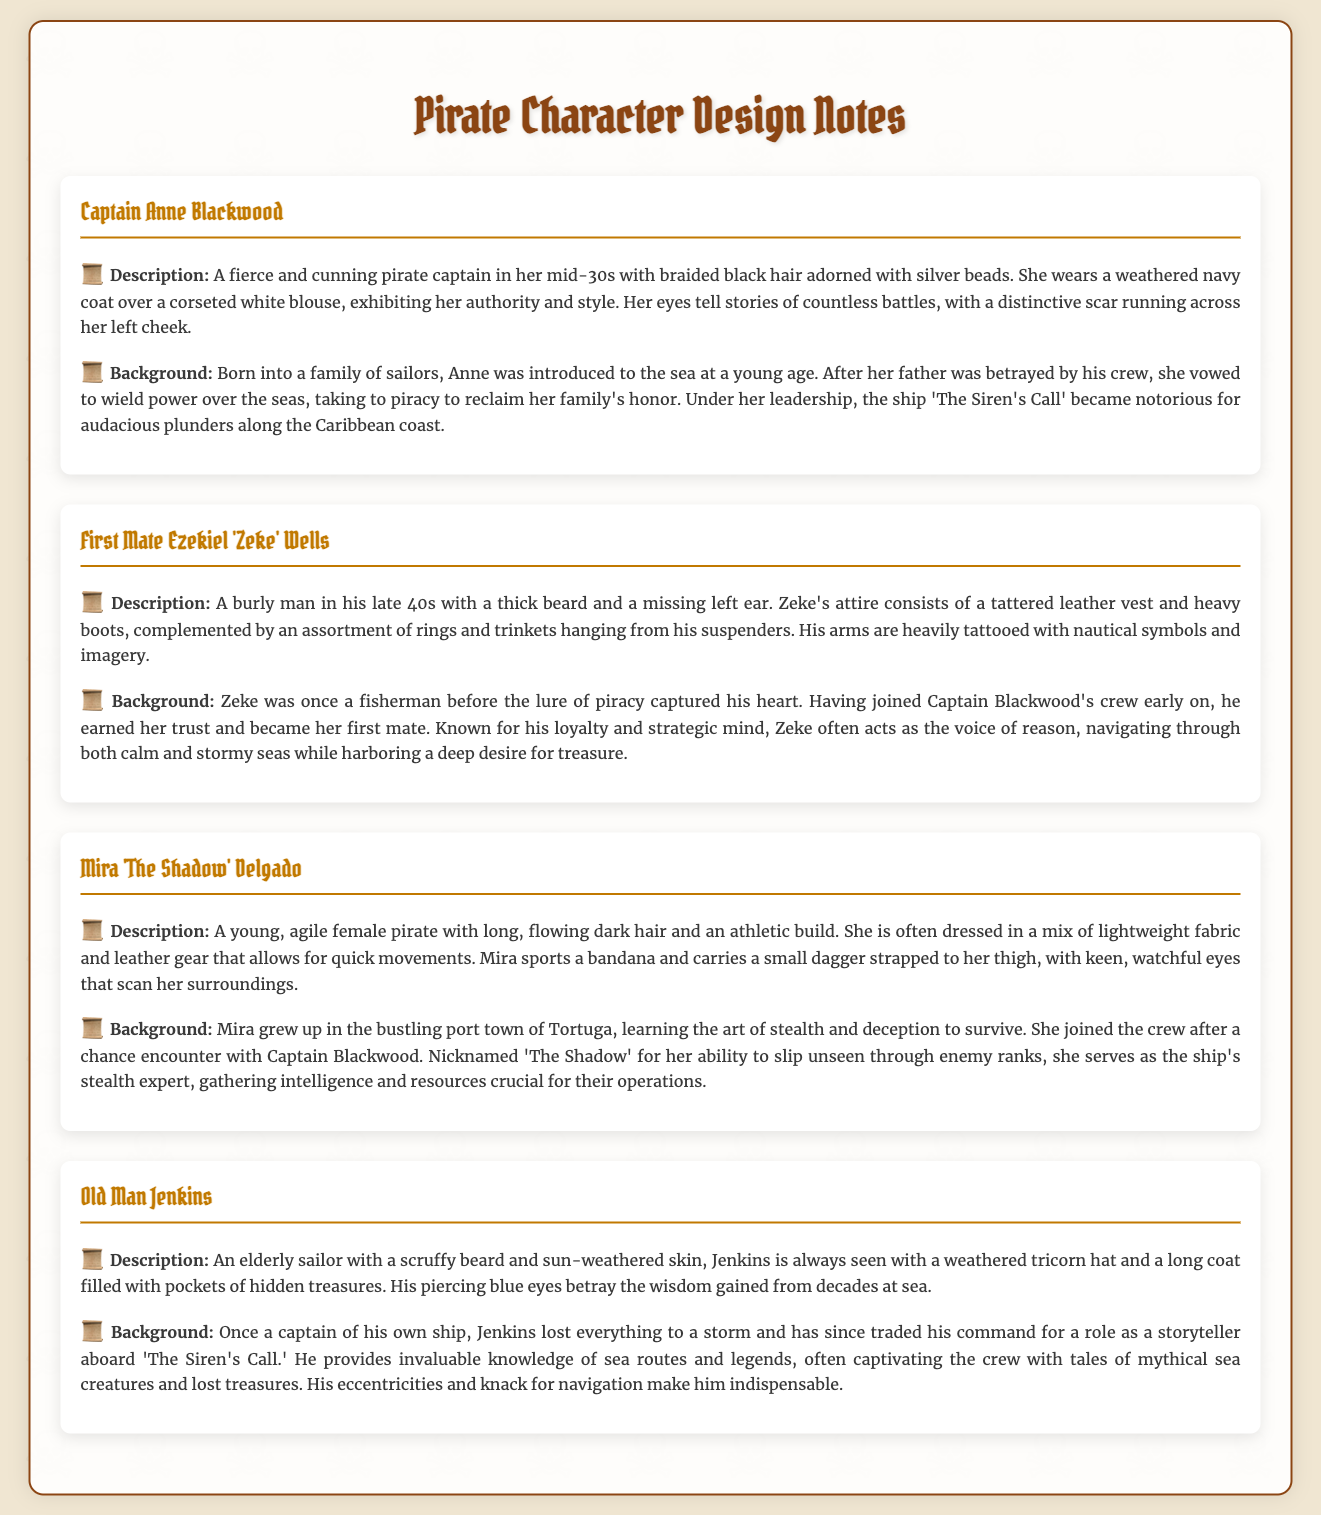What is the name of the pirate captain? The document provides detailed character design notes and the name of the pirate captain is mentioned as Captain Anne Blackwood.
Answer: Captain Anne Blackwood How old is Captain Anne Blackwood? The document specifies that Captain Anne Blackwood is in her mid-30s.
Answer: mid-30s What is First Mate Ezekiel's nickname? The document identifies First Mate Ezekiel Wells by his nickname, which is 'Zeke'.
Answer: Zeke What significant feature does Zeke have? The document describes that Zeke has a missing left ear, highlighting a significant aspect of his character.
Answer: missing left ear Where did Mira grow up? According to the background information in the document, Mira grew up in Tortuga.
Answer: Tortuga Which ship does Old Man Jenkins tell stories on? The document states that Old Man Jenkins shares his tales aboard 'The Siren's Call'.
Answer: The Siren's Call What is the primary role of Mira on the ship? The document mentions that Mira serves as the ship's stealth expert.
Answer: stealth expert What type of coat does Captain Anne Blackwood wear? The document specifies that Anne Blackwood wears a weathered navy coat.
Answer: weathered navy coat What is a notable background detail about Captain Anne Blackwood's past? The document notes that Anne's father was betrayed by his crew, shaping her motivation for piracy.
Answer: father was betrayed by his crew 